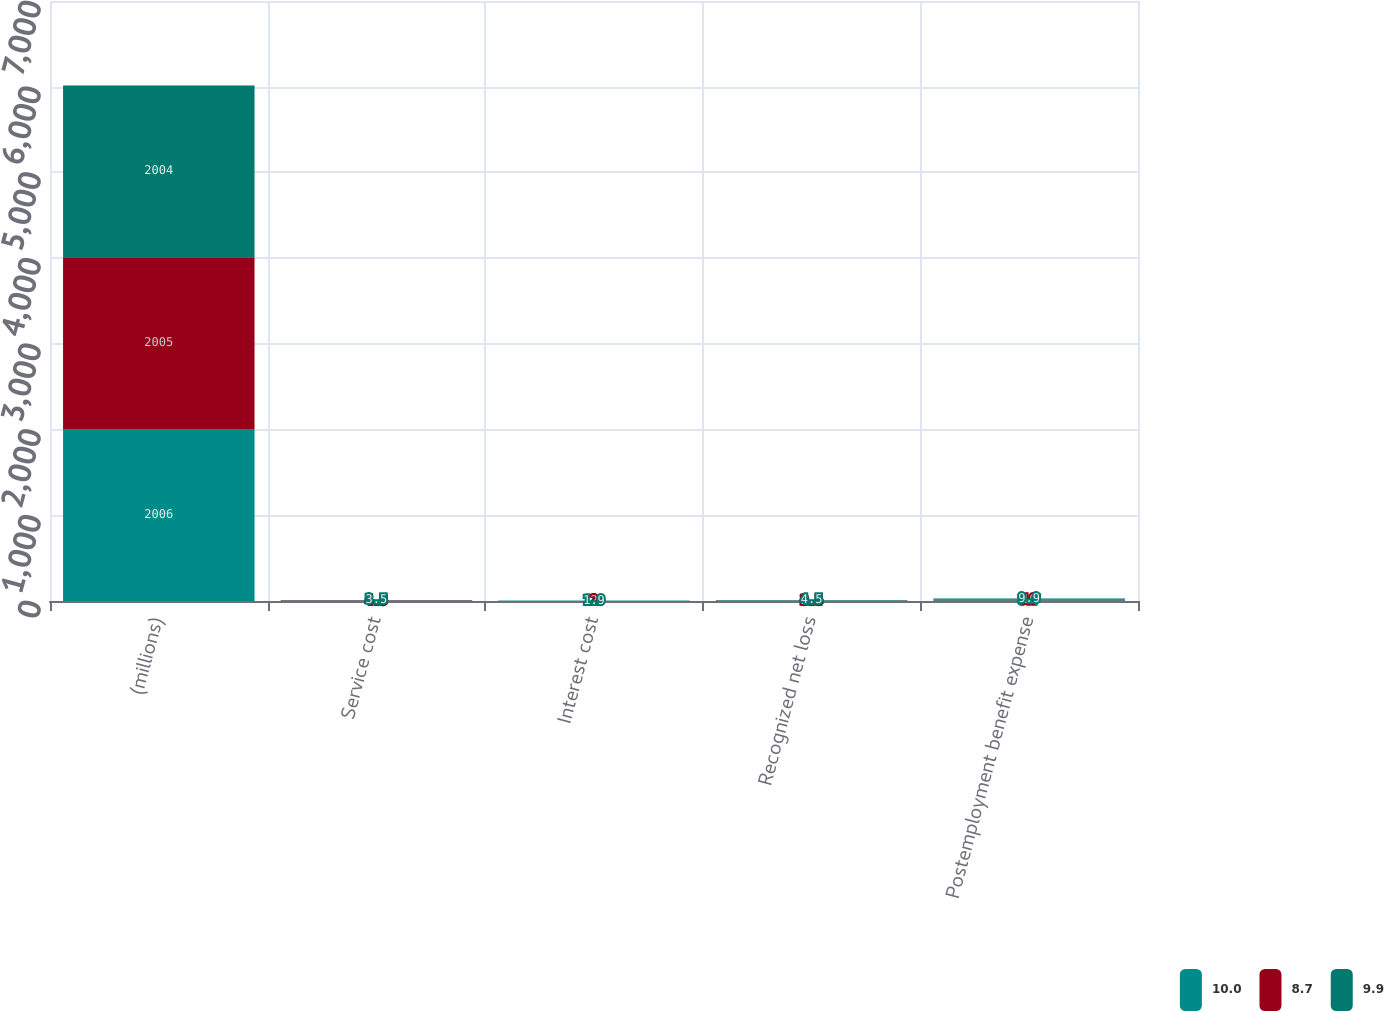Convert chart. <chart><loc_0><loc_0><loc_500><loc_500><stacked_bar_chart><ecel><fcel>(millions)<fcel>Service cost<fcel>Interest cost<fcel>Recognized net loss<fcel>Postemployment benefit expense<nl><fcel>10<fcel>2006<fcel>4.3<fcel>2<fcel>2.4<fcel>8.7<nl><fcel>8.7<fcel>2005<fcel>4.5<fcel>2<fcel>3.5<fcel>10<nl><fcel>9.9<fcel>2004<fcel>3.5<fcel>1.9<fcel>4.5<fcel>9.9<nl></chart> 